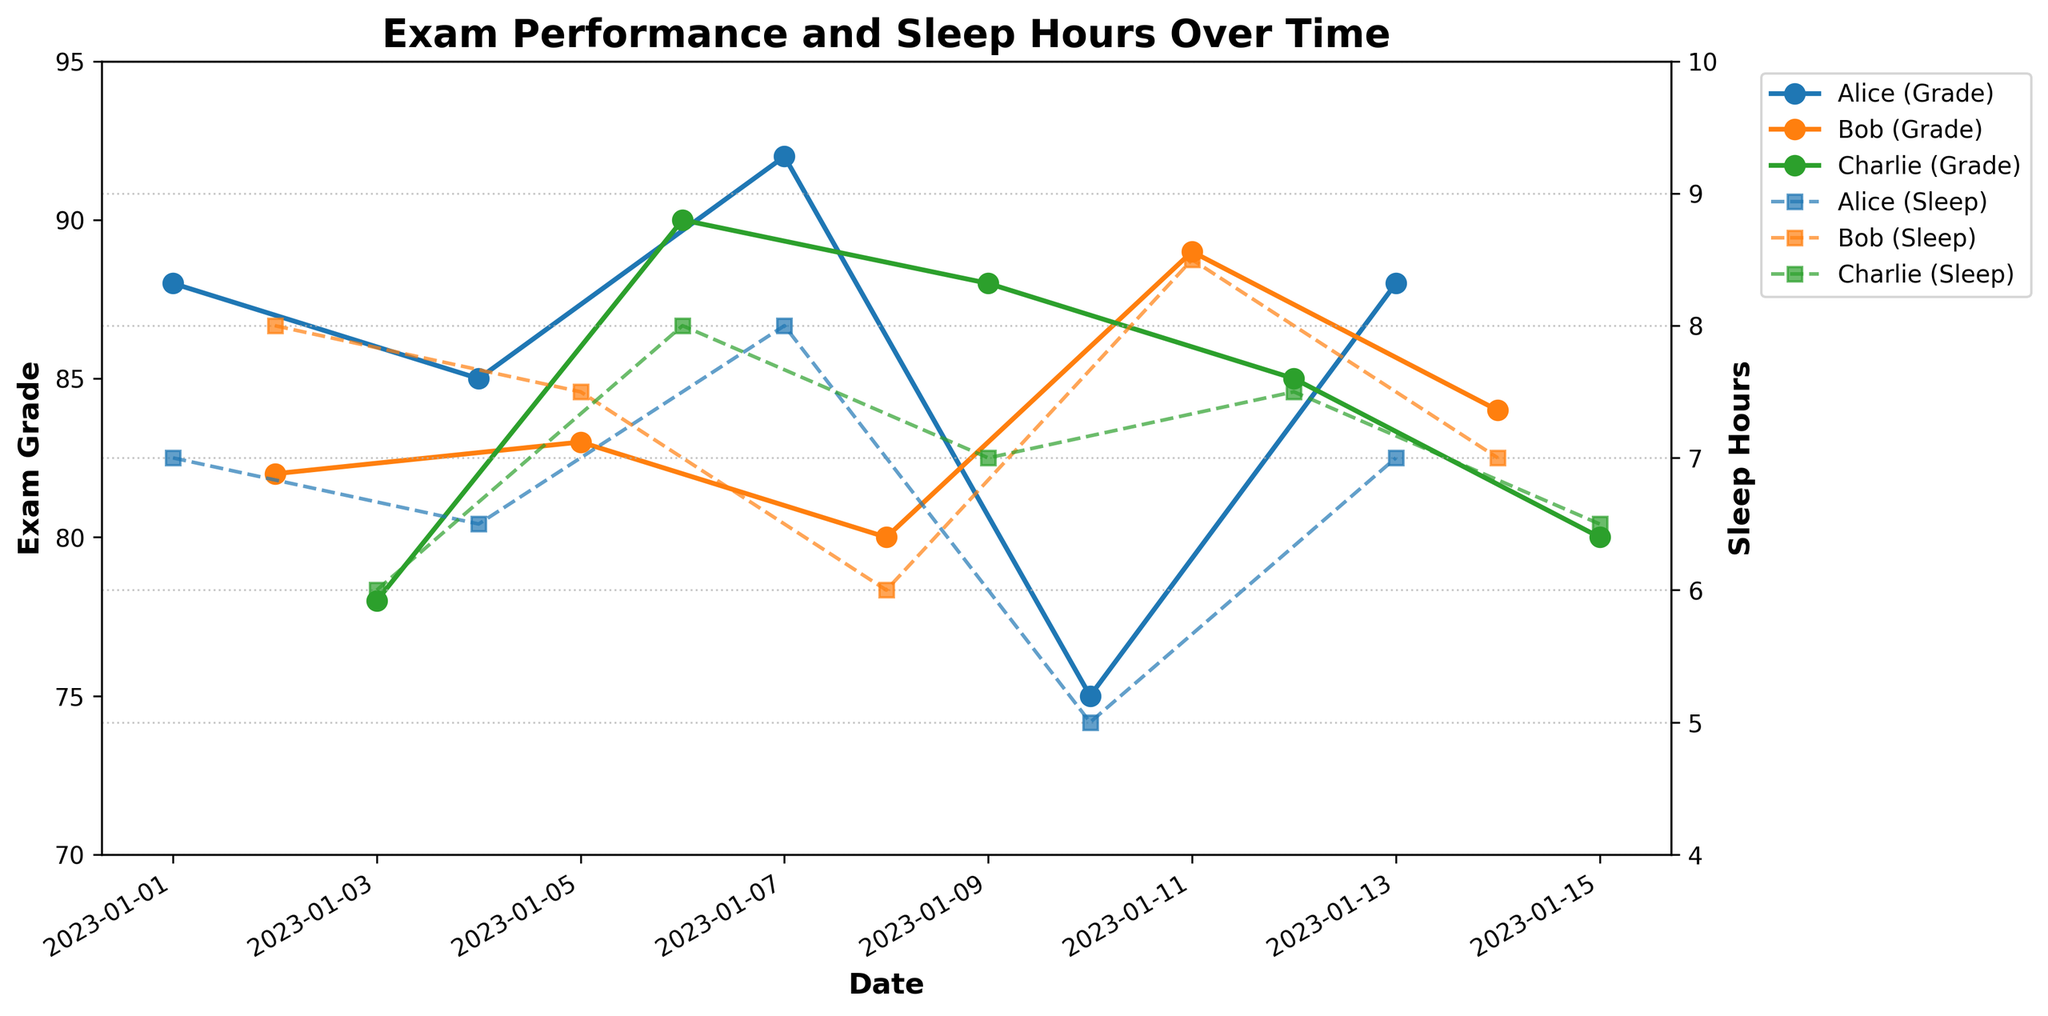What is the title of the plot? Look at the top center of the plot where the title is usually displayed.
Answer: Exam Performance and Sleep Hours Over Time What are the axes labels in the figure? The label for the x-axis is at the bottom of the plot, and the labels for the y-axes are on the left and right sides of the plot. The x-axis is labeled 'Date', the left y-axis is labeled 'Exam Grade', and the right y-axis is labeled 'Sleep Hours'.
Answer: Date, Exam Grade, Sleep Hours Which student had the highest exam grade? Look for the highest data point on the Exam Grade axis and check the corresponding legend.
Answer: Alice On which date did Bob sleep the most? Trace Bob's sleep hours data points and find the highest point. The corresponding date is on the x-axis directly below this point.
Answer: 2023-01-11 What is Bob’s average sleep hours over the period? Add up all of Bob's sleep hours and then divide by the number of days he is recorded. (8 + 7.5 + 6 + 8.5 + 7) / 5 = 37 / 5
Answer: 7.4 How does the change in Alice's sleep hours correlate with her exam grades? Observe the trend lines of Alice’s sleep hours and exam grades. Check if increases in sleep hours correspond to increases in exam grades, and vice versa.
Answer: Positive correlation; when Alice's sleep hours increase, her exam grades tend to increase as well Which student shows the most variation in their exam grades? Look at the range between the highest and lowest exam grades for each student. Compare these ranges to determine the highest variation.
Answer: Charlie On which date did Charlie get a perfect score? Find the date where Charlie’s exam grade reaches its peak value of 90.
Answer: 2023-01-06 What is the relationship between Bob's sleep hours and exam grades on January 11? Check Bob's data for January 11 and compare his sleep hours and exam grade on that date. He slept 8.5 hours and had an exam grade of 89.
Answer: Positive relationship; more sleep correlates with a higher exam grade Compare the sleep hours of all three students on January 7. Who had the most and who had the least sleep? Look at the sleep hours data points for January 7 for each student. Alice had 8 hours, Bob is not plotted, and Charlie's data is not plotted.
Answer: Alice most, data not complete for others 